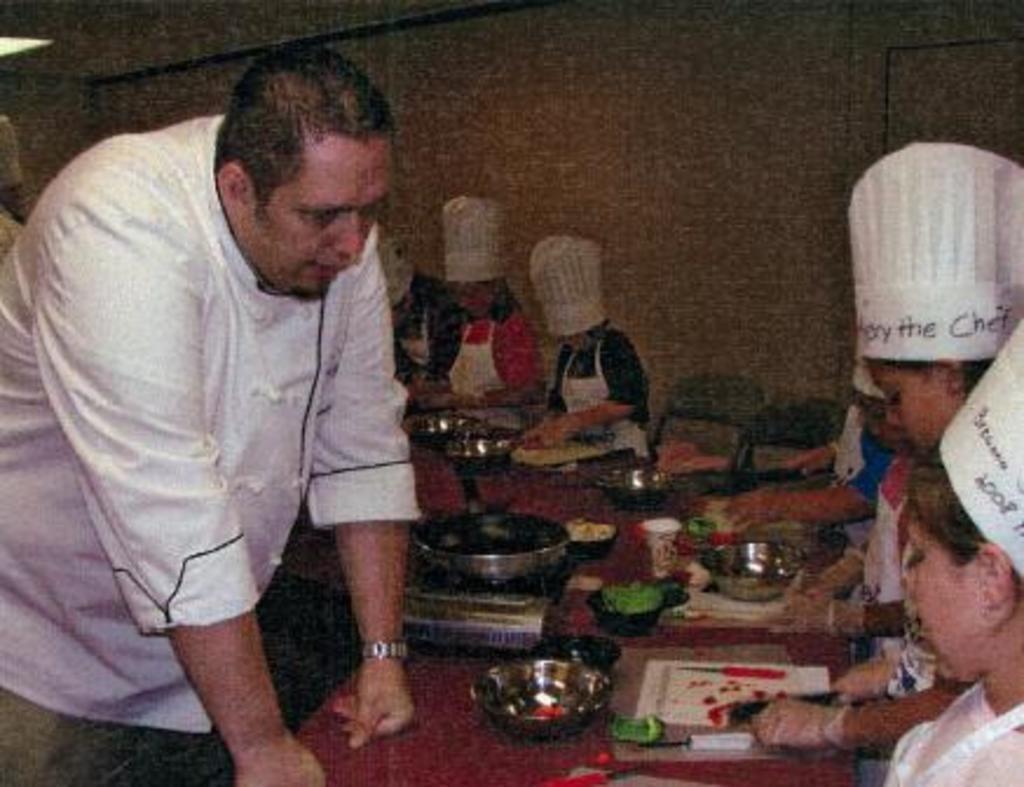Can you describe this image briefly? In this picture, we can see a few people, we can see some objects on the table like pan, bowls and we can see the wall and light. 